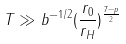Convert formula to latex. <formula><loc_0><loc_0><loc_500><loc_500>T \gg b ^ { - 1 / 2 } ( \frac { r _ { 0 } } { r _ { H } } ) ^ { \frac { 7 - p } { 2 } }</formula> 